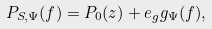Convert formula to latex. <formula><loc_0><loc_0><loc_500><loc_500>P _ { S , \Psi } ( f ) = P _ { 0 } ( z ) + e _ { g } g _ { \Psi } ( f ) ,</formula> 